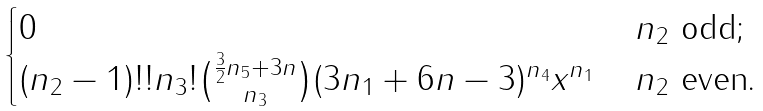<formula> <loc_0><loc_0><loc_500><loc_500>\begin{cases} 0 & \, n _ { 2 } \text { odd} ; \\ ( n _ { 2 } - 1 ) ! ! n _ { 3 } ! \binom { \frac { 3 } { 2 } n _ { 5 } + 3 n } { n _ { 3 } } ( 3 n _ { 1 } + 6 n - 3 ) ^ { n _ { 4 } } x ^ { n _ { 1 } } & \, n _ { 2 } \text { even.} \end{cases}</formula> 